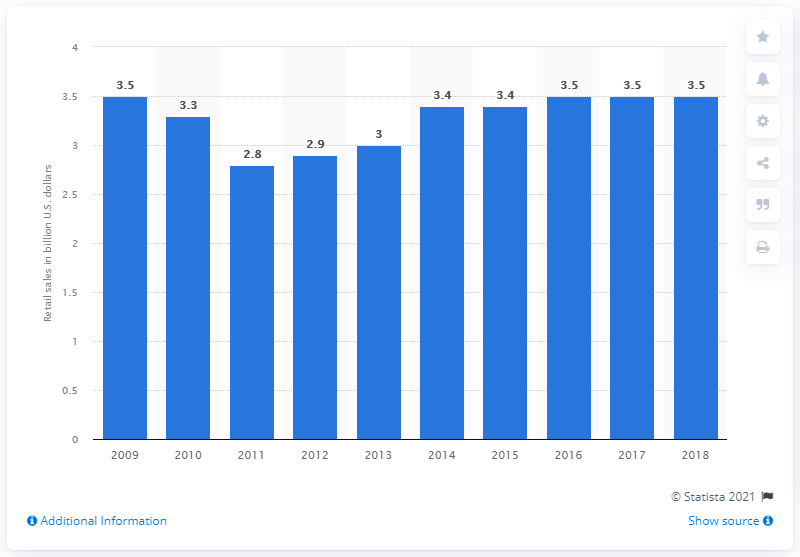List a handful of essential elements in this visual. In 2018, the total retail sales of the confectionery industry in Canada amounted to CAD 3.5 billion. 